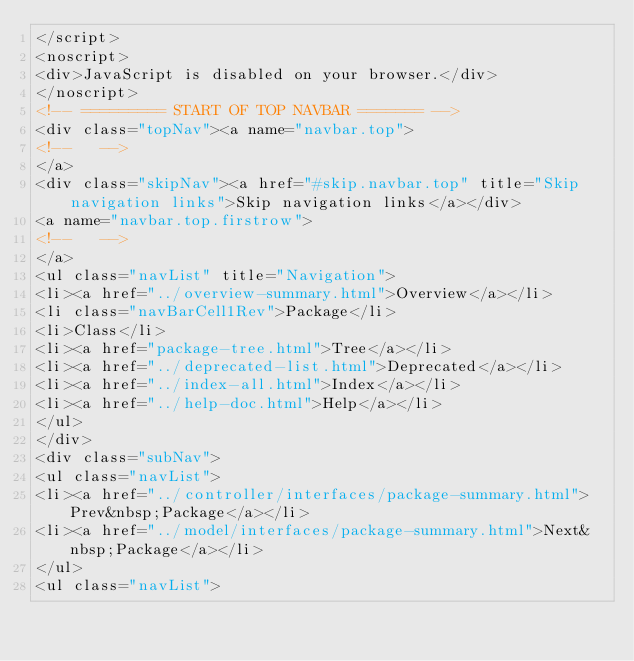<code> <loc_0><loc_0><loc_500><loc_500><_HTML_></script>
<noscript>
<div>JavaScript is disabled on your browser.</div>
</noscript>
<!-- ========= START OF TOP NAVBAR ======= -->
<div class="topNav"><a name="navbar.top">
<!--   -->
</a>
<div class="skipNav"><a href="#skip.navbar.top" title="Skip navigation links">Skip navigation links</a></div>
<a name="navbar.top.firstrow">
<!--   -->
</a>
<ul class="navList" title="Navigation">
<li><a href="../overview-summary.html">Overview</a></li>
<li class="navBarCell1Rev">Package</li>
<li>Class</li>
<li><a href="package-tree.html">Tree</a></li>
<li><a href="../deprecated-list.html">Deprecated</a></li>
<li><a href="../index-all.html">Index</a></li>
<li><a href="../help-doc.html">Help</a></li>
</ul>
</div>
<div class="subNav">
<ul class="navList">
<li><a href="../controller/interfaces/package-summary.html">Prev&nbsp;Package</a></li>
<li><a href="../model/interfaces/package-summary.html">Next&nbsp;Package</a></li>
</ul>
<ul class="navList"></code> 